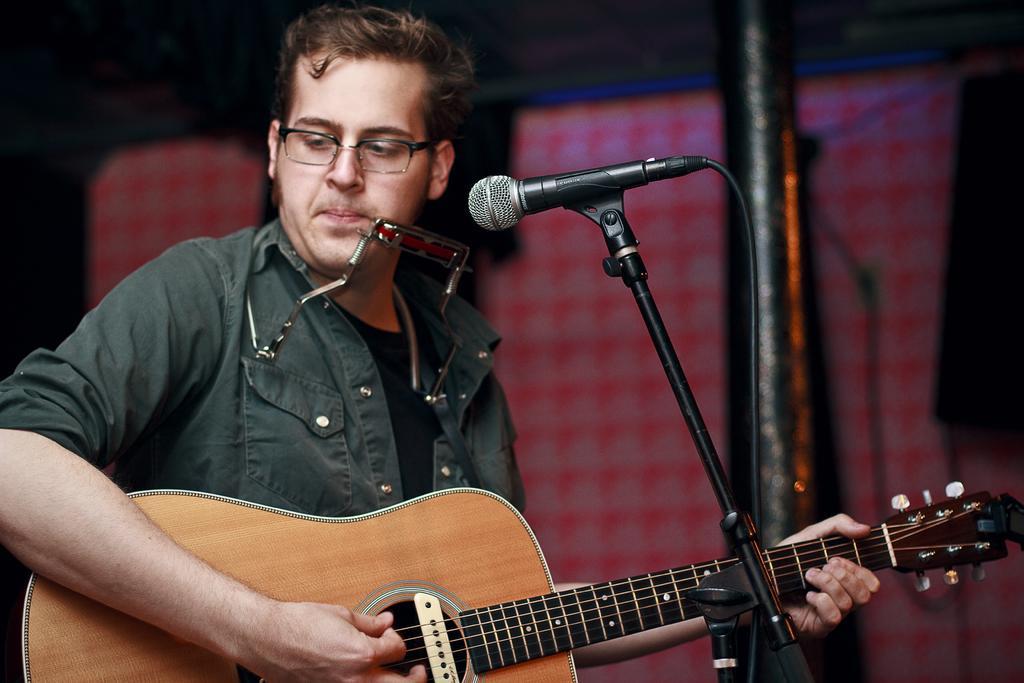How would you summarize this image in a sentence or two? in the picture a person is holding a guitar and singing in microphone which is in front of him. 